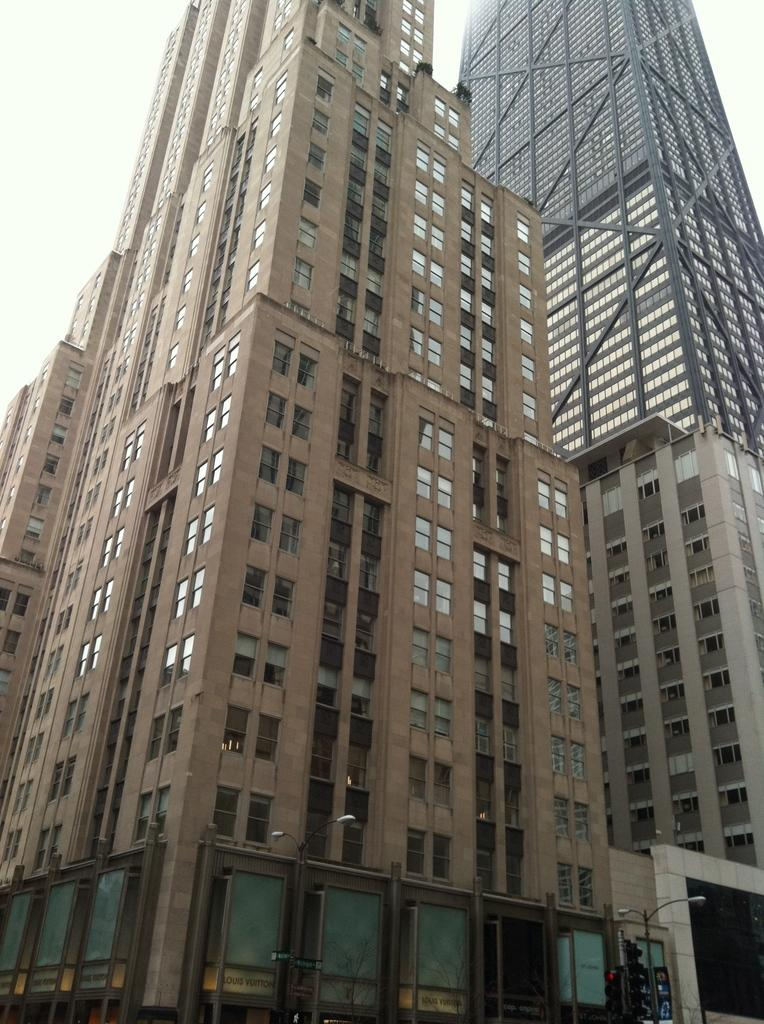What is the main structure in the image? There is a building in the image. What color is the main building? The building is brown in color. Are there any other buildings in the image? Yes, there are other buildings around the main building. What can be seen in the background of the image? The sky is visible in the background of the image. How many roses are on the yoke of the building in the image? There are no roses or yokes present on the building in the image. What type of cherries can be seen growing on the building in the image? There are no cherries present on the building in the image. 